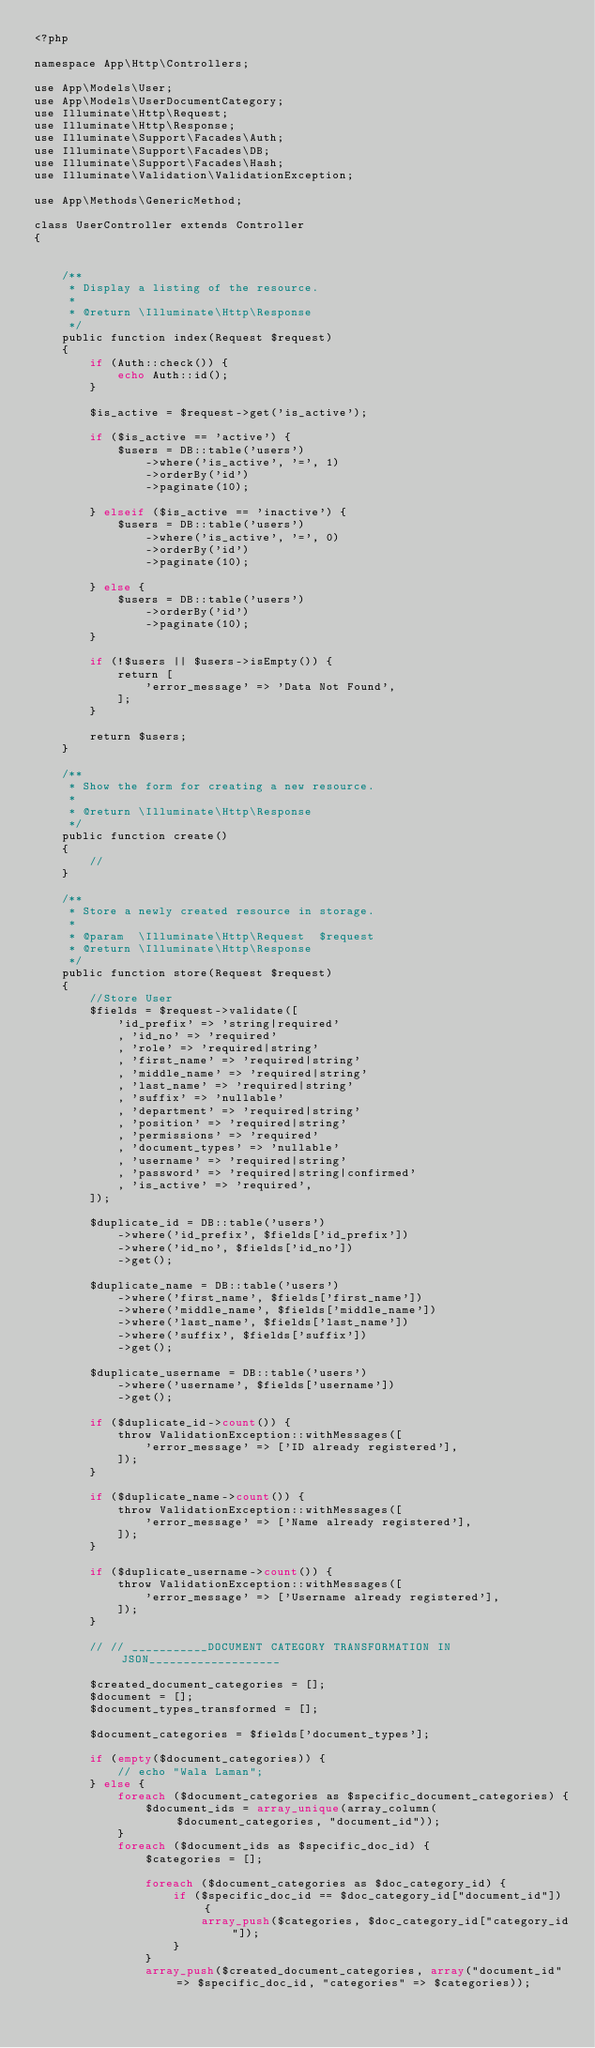<code> <loc_0><loc_0><loc_500><loc_500><_PHP_><?php

namespace App\Http\Controllers;

use App\Models\User;
use App\Models\UserDocumentCategory;
use Illuminate\Http\Request;
use Illuminate\Http\Response;
use Illuminate\Support\Facades\Auth;
use Illuminate\Support\Facades\DB;
use Illuminate\Support\Facades\Hash;
use Illuminate\Validation\ValidationException;

use App\Methods\GenericMethod;

class UserController extends Controller
{


    /**
     * Display a listing of the resource.
     *
     * @return \Illuminate\Http\Response
     */
    public function index(Request $request)
    {
        if (Auth::check()) {
            echo Auth::id();
        }

        $is_active = $request->get('is_active');

        if ($is_active == 'active') {
            $users = DB::table('users')
                ->where('is_active', '=', 1)
                ->orderBy('id')
                ->paginate(10);

        } elseif ($is_active == 'inactive') {
            $users = DB::table('users')
                ->where('is_active', '=', 0)
                ->orderBy('id')
                ->paginate(10);

        } else {
            $users = DB::table('users')
                ->orderBy('id')
                ->paginate(10);
        }

        if (!$users || $users->isEmpty()) {
            return [
                'error_message' => 'Data Not Found',
            ];
        }

        return $users;
    }

    /**
     * Show the form for creating a new resource.
     *
     * @return \Illuminate\Http\Response
     */
    public function create()
    {
        //
    }

    /**
     * Store a newly created resource in storage.
     *
     * @param  \Illuminate\Http\Request  $request
     * @return \Illuminate\Http\Response
     */
    public function store(Request $request)
    {
        //Store User
        $fields = $request->validate([
            'id_prefix' => 'string|required'
            , 'id_no' => 'required'
            , 'role' => 'required|string'
            , 'first_name' => 'required|string'
            , 'middle_name' => 'required|string'
            , 'last_name' => 'required|string'
            , 'suffix' => 'nullable'
            , 'department' => 'required|string'
            , 'position' => 'required|string'
            , 'permissions' => 'required'
            , 'document_types' => 'nullable'
            , 'username' => 'required|string'
            , 'password' => 'required|string|confirmed'
            , 'is_active' => 'required',
        ]);

        $duplicate_id = DB::table('users')
            ->where('id_prefix', $fields['id_prefix'])
            ->where('id_no', $fields['id_no'])
            ->get();

        $duplicate_name = DB::table('users')
            ->where('first_name', $fields['first_name'])
            ->where('middle_name', $fields['middle_name'])
            ->where('last_name', $fields['last_name'])
            ->where('suffix', $fields['suffix'])
            ->get();

        $duplicate_username = DB::table('users')
            ->where('username', $fields['username'])
            ->get();

        if ($duplicate_id->count()) {
            throw ValidationException::withMessages([
                'error_message' => ['ID already registered'],
            ]);
        }

        if ($duplicate_name->count()) {
            throw ValidationException::withMessages([
                'error_message' => ['Name already registered'],
            ]);
        }

        if ($duplicate_username->count()) {
            throw ValidationException::withMessages([
                'error_message' => ['Username already registered'],
            ]);
        }

        // // ___________DOCUMENT CATEGORY TRANSFORMATION IN JSON___________________

        $created_document_categories = [];
        $document = [];
        $document_types_transformed = [];

        $document_categories = $fields['document_types'];

        if (empty($document_categories)) {
            // echo "Wala Laman";
        } else {
            foreach ($document_categories as $specific_document_categories) {
                $document_ids = array_unique(array_column($document_categories, "document_id"));
            }
            foreach ($document_ids as $specific_doc_id) {
                $categories = [];

                foreach ($document_categories as $doc_category_id) {
                    if ($specific_doc_id == $doc_category_id["document_id"]) {
                        array_push($categories, $doc_category_id["category_id"]);
                    }
                }
                array_push($created_document_categories, array("document_id" => $specific_doc_id, "categories" => $categories));</code> 